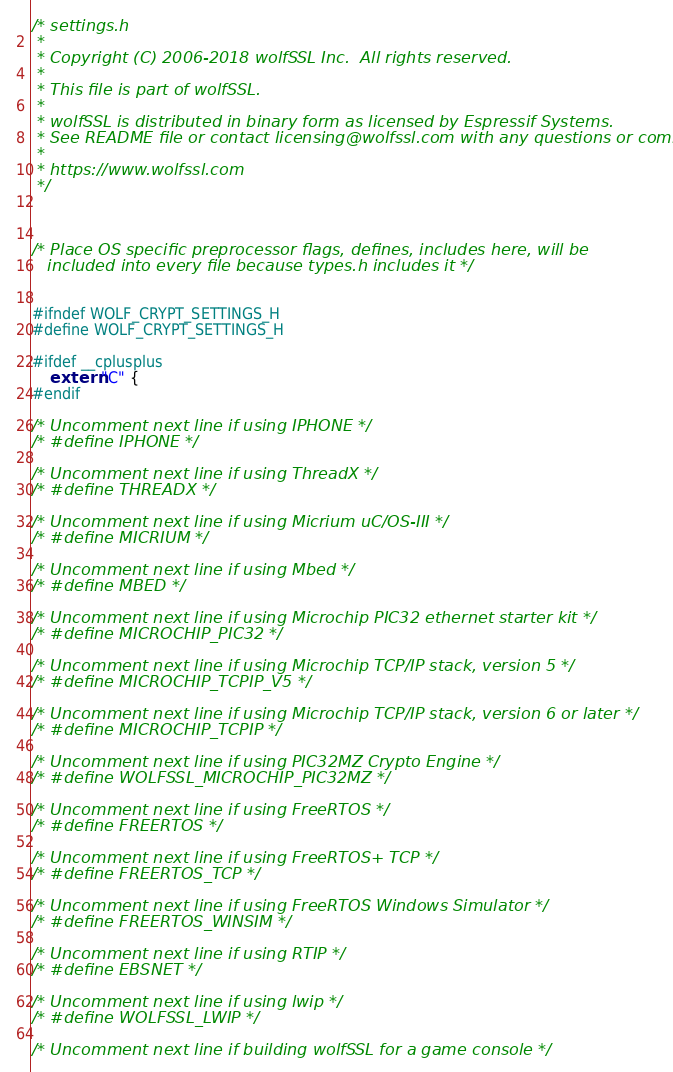<code> <loc_0><loc_0><loc_500><loc_500><_C_>/* settings.h
 *
 * Copyright (C) 2006-2018 wolfSSL Inc.  All rights reserved.
 *
 * This file is part of wolfSSL.
 *
 * wolfSSL is distributed in binary form as licensed by Espressif Systems.
 * See README file or contact licensing@wolfssl.com with any questions or comments.
 *
 * https://www.wolfssl.com
 */



/* Place OS specific preprocessor flags, defines, includes here, will be
   included into every file because types.h includes it */


#ifndef WOLF_CRYPT_SETTINGS_H
#define WOLF_CRYPT_SETTINGS_H

#ifdef __cplusplus
    extern "C" {
#endif

/* Uncomment next line if using IPHONE */
/* #define IPHONE */

/* Uncomment next line if using ThreadX */
/* #define THREADX */

/* Uncomment next line if using Micrium uC/OS-III */
/* #define MICRIUM */

/* Uncomment next line if using Mbed */
/* #define MBED */

/* Uncomment next line if using Microchip PIC32 ethernet starter kit */
/* #define MICROCHIP_PIC32 */

/* Uncomment next line if using Microchip TCP/IP stack, version 5 */
/* #define MICROCHIP_TCPIP_V5 */

/* Uncomment next line if using Microchip TCP/IP stack, version 6 or later */
/* #define MICROCHIP_TCPIP */

/* Uncomment next line if using PIC32MZ Crypto Engine */
/* #define WOLFSSL_MICROCHIP_PIC32MZ */

/* Uncomment next line if using FreeRTOS */
/* #define FREERTOS */

/* Uncomment next line if using FreeRTOS+ TCP */
/* #define FREERTOS_TCP */

/* Uncomment next line if using FreeRTOS Windows Simulator */
/* #define FREERTOS_WINSIM */

/* Uncomment next line if using RTIP */
/* #define EBSNET */

/* Uncomment next line if using lwip */
/* #define WOLFSSL_LWIP */

/* Uncomment next line if building wolfSSL for a game console */</code> 